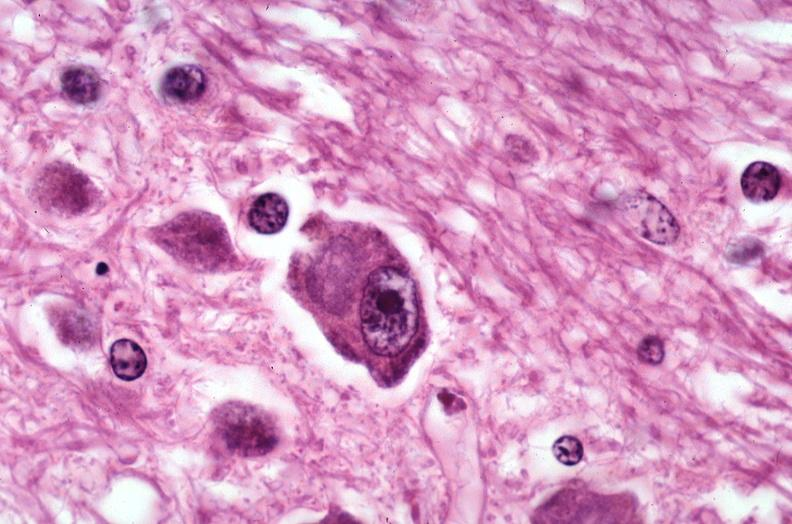what does this image show?
Answer the question using a single word or phrase. Brain 